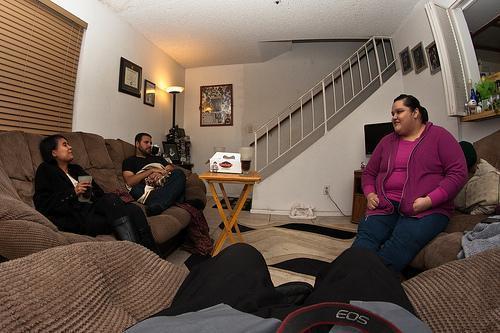How many people are fully or partially visible?
Give a very brief answer. 4. How many people are sitting on the couch on the left?
Give a very brief answer. 2. How many lamps are there?
Give a very brief answer. 1. How many people are wearing pink shirt?
Give a very brief answer. 0. 